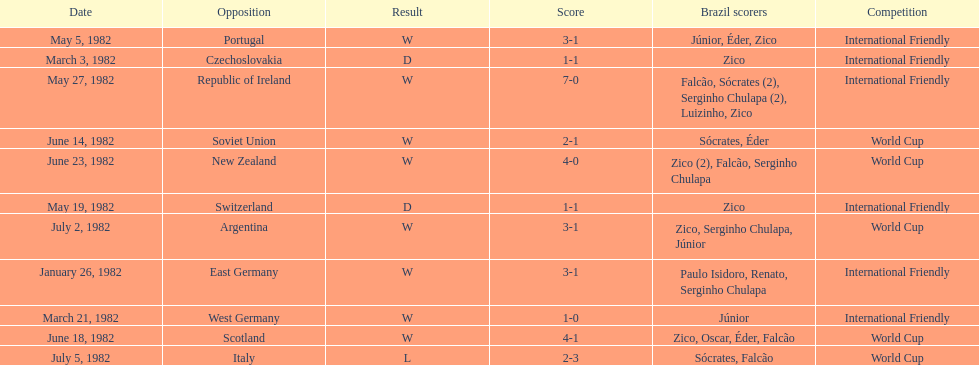What is the number of games won by brazil during the month of march 1982? 1. 